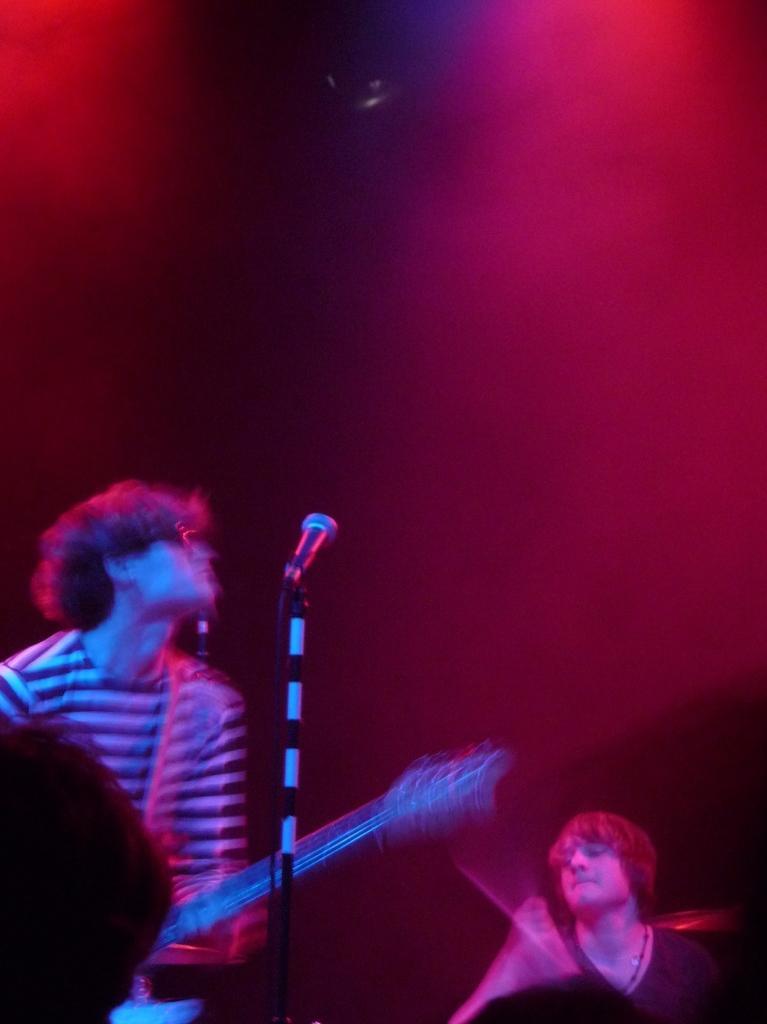In one or two sentences, can you explain what this image depicts? In this image there is a man who is holding the guitar. In front of him there is a mic. At the top there are two lights, Beside him there is another person. At the bottom we can see the head of a person. 